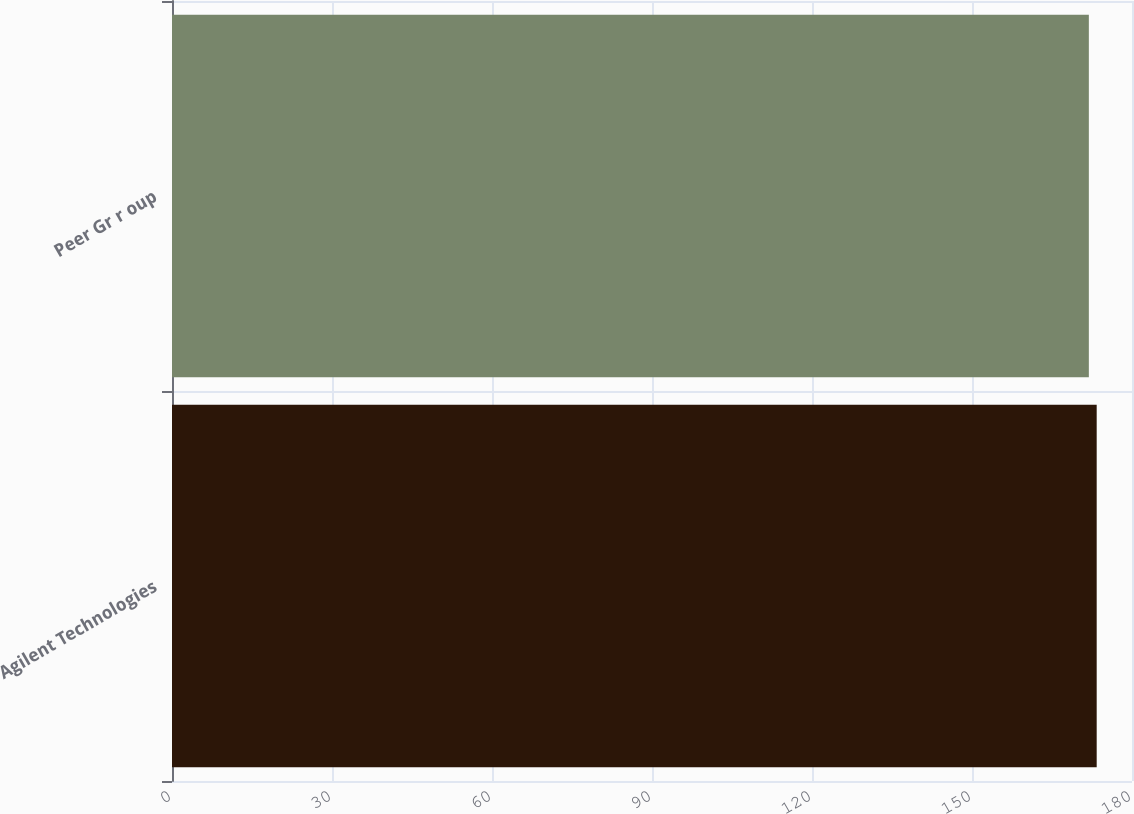Convert chart. <chart><loc_0><loc_0><loc_500><loc_500><bar_chart><fcel>Agilent Technologies<fcel>Peer Gr r oup<nl><fcel>173.38<fcel>171.91<nl></chart> 